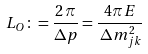Convert formula to latex. <formula><loc_0><loc_0><loc_500><loc_500>L _ { O } \colon = \frac { 2 \, \pi } { \Delta p } = \frac { 4 \pi E } { \, \Delta m _ { j k } ^ { 2 } }</formula> 